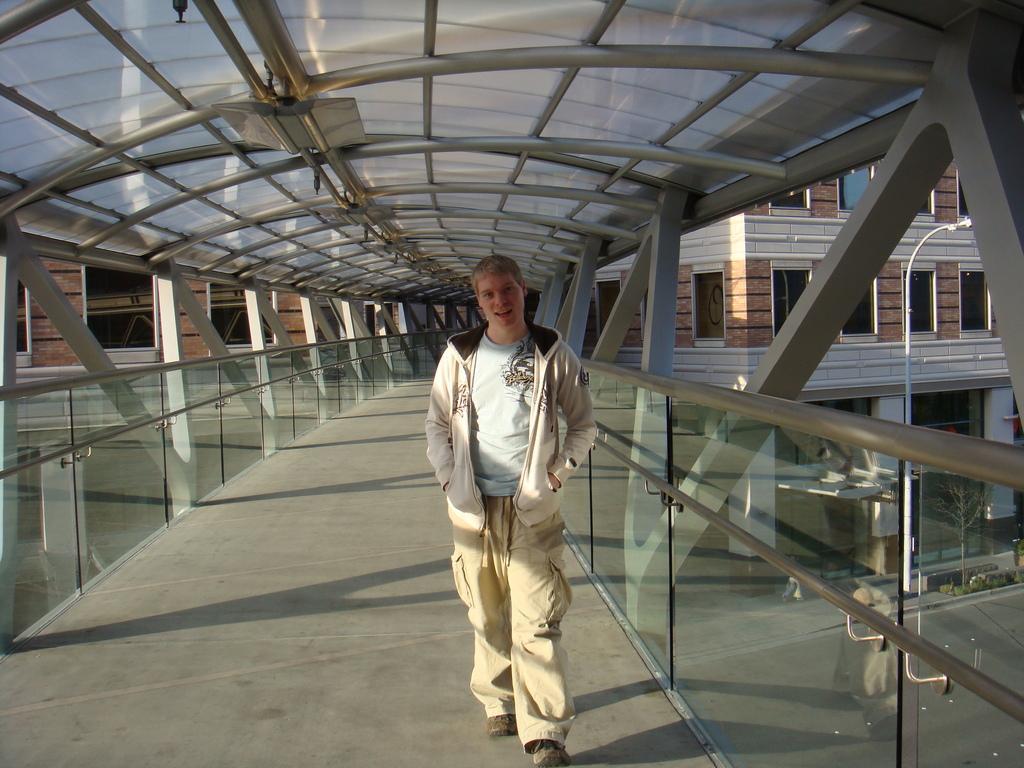In one or two sentences, can you explain what this image depicts? In this picture there is a man who is wearing jacket, t-shirt, trouser and shoe. He is standing near to the glass fencing. At the top there is a shed. In the background I can see the buildings. In the bottom right corner I can see two persons were standing on the road, besides them there is a pole and plant. 